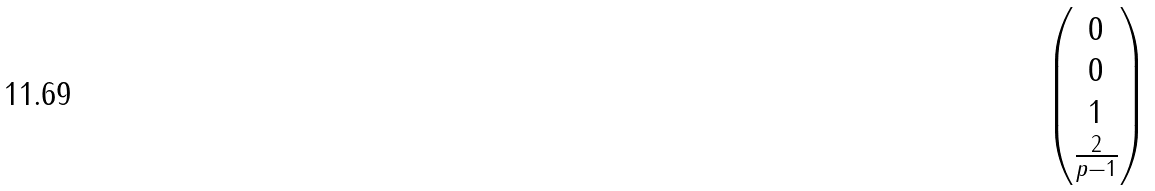<formula> <loc_0><loc_0><loc_500><loc_500>\begin{pmatrix} 0 \\ 0 \\ 1 \\ \frac { 2 } { p - 1 } \end{pmatrix}</formula> 